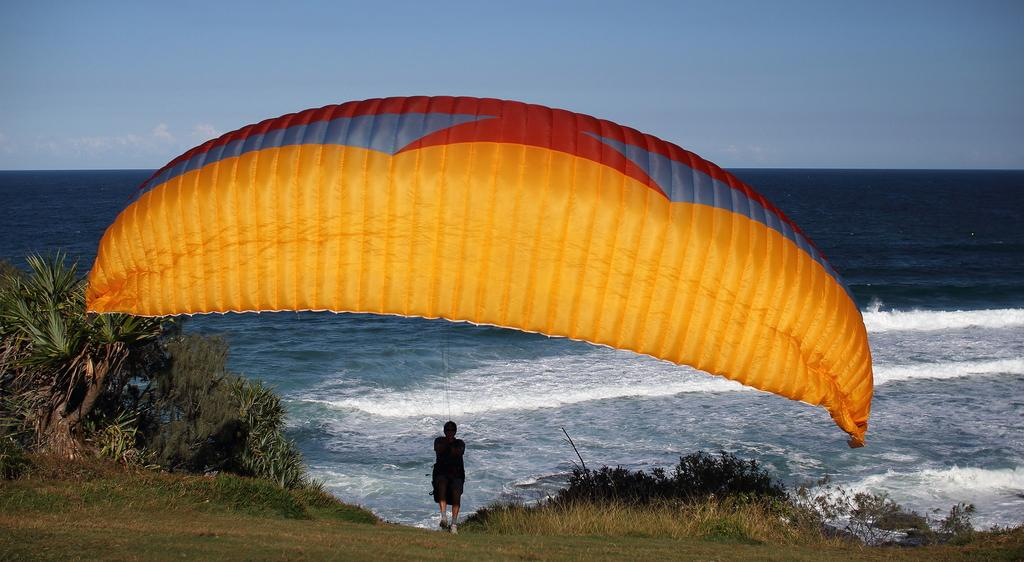Who is present in the image? There is a man in the image. What is the man standing on? The man is standing on grass land. What is the man holding or wearing that is related to skydiving? The man has a parachute. What can be seen in the distance behind the man? There is an ocean in the background of the image. What is visible above the man? The sky is visible above the man. What statement is the man making in the image? There is no indication in the image that the man is making a statement. Can you see any skateboards in the image? There are no skateboards present in the image. 